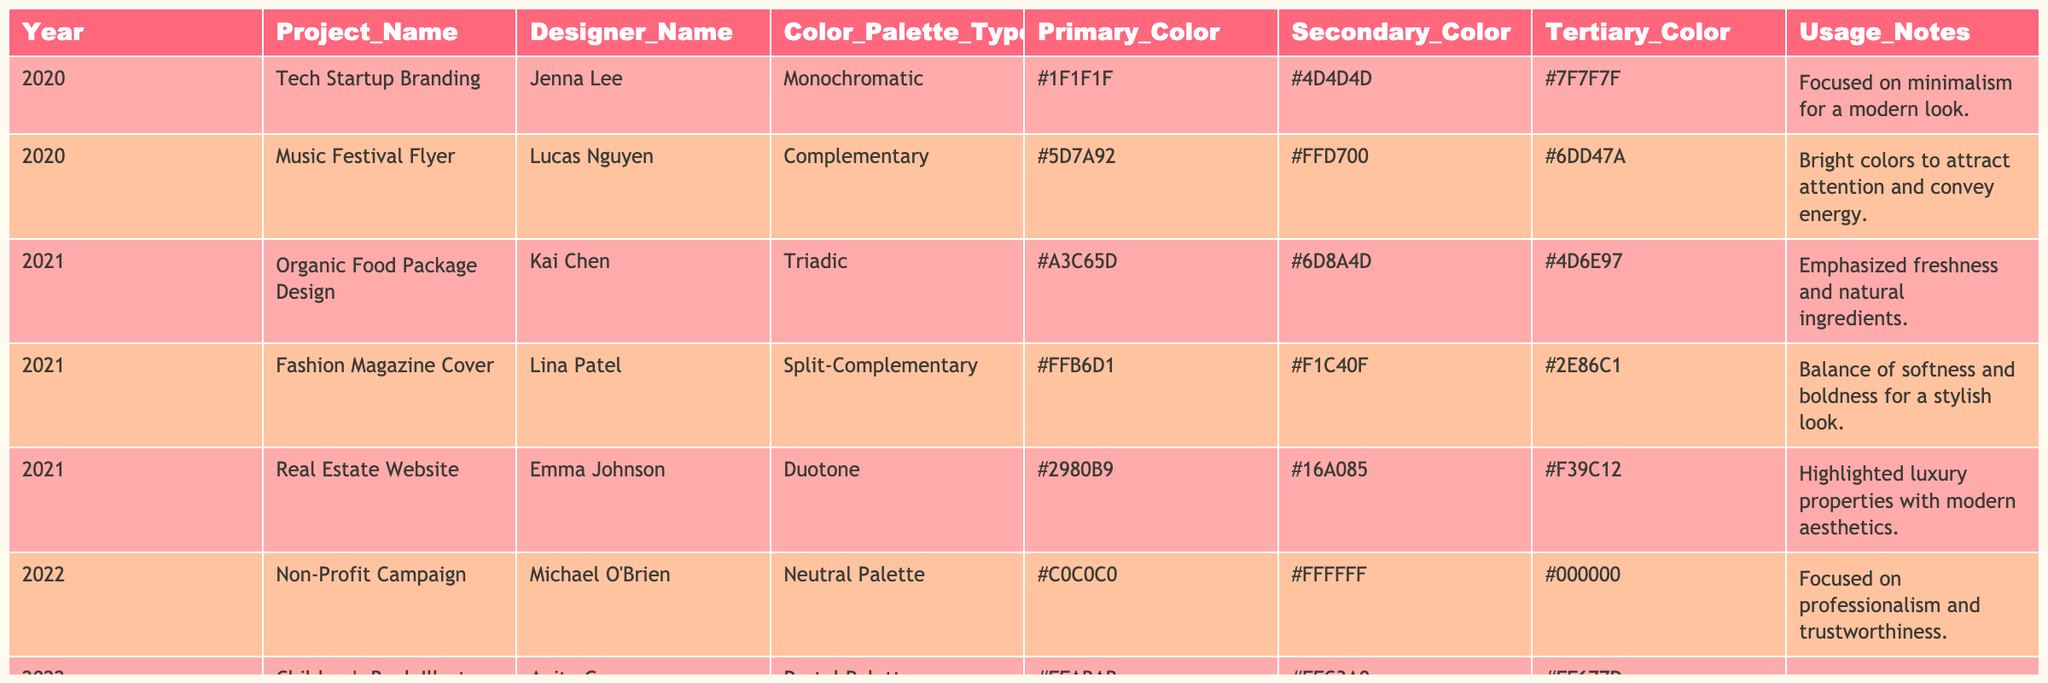What color palette type was used for the Music Festival Flyer? The table shows that the Music Festival Flyer project used a Complementary color palette type.
Answer: Complementary Which project utilized a Monochromatic color palette? According to the table, the Tech Startup Branding project utilized a Monochromatic color palette.
Answer: Tech Startup Branding How many projects used a Tertiary color of #6DD47A? The project "Music Festival Flyer" has this Tertiary color. Therefore, only one project used #6DD47A as a Tertiary color.
Answer: 1 What is the primary color of the Fashion Magazine Cover? The table indicates that the primary color of the Fashion Magazine Cover is #FFB6D1.
Answer: #FFB6D1 Did any projects in 2022 use a Dynamic Palette? The table lists the Video Game Branding project as using a Dynamic Palette in 2022.
Answer: Yes What year had the most projects listed in the table? There are three projects listed for 2021, which is more than any other year. Therefore, 2021 had the most projects.
Answer: 2021 What is the difference in primary colors between the 2020 Tech Startup Branding and the 2023 Beauty Product Ad? The primary color for Tech Startup Branding is #1F1F1F and for Beauty Product Ad is #BDAE9E. The two colors are different, therefore it indicates variance in color usage across years.
Answer: They are different Which designer worked on an Organic Food Package Design, and what color palette did they use? The table shows that Kai Chen designed the Organic Food Package and used a Triadic color palette.
Answer: Kai Chen, Triadic How many projects used Earthy Tones as a color palette type? Only one project, the Beauty Product Ad, used Earthy Tones as indicated in the table.
Answer: 1 What is the commonality in color palettes used for projects in the year 2021? In 2021, the projects featured three types of color palettes: Triadic, Split-Complementary, and Duotone, which indicates a variety of approaches within that year.
Answer: Variety of palettes Which project had the secondary color of #FFFFFF? The Non-Profit Campaign project had #FFFFFF as its secondary color, according to the table.
Answer: Non-Profit Campaign What was the primary color of the Corporate Presentation in 2023? The primary color used in the Corporate Presentation is #2C3E50, according to the table.
Answer: #2C3E50 How many different color palette types were used across all the projects from 2020 to 2023? Analyzing the color palette types in the table, there are eight distinct types listed: Monochromatic, Complementary, Triadic, Split-Complementary, Duotone, Neutral Palette, Pastel Palette, Dynamic Palette, Earthy Tones, and Corporate Palette. Thus, there are ten types in total.
Answer: 10 Which designer has worked on the most high-energy projects based on color palette usage? Looking at the energy levels suggested by the colors used, Lucas Nguyen's Music Festival Flyer (Complementary) and Tony Martinez's Video Game Branding (Dynamic Palette) can be highlighted as high-energy projects, but they belong to different designers. Each designer has only one high-energy project listed here.
Answer: Tie 